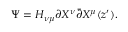Convert formula to latex. <formula><loc_0><loc_0><loc_500><loc_500>\Psi = H _ { \nu \mu } \partial X ^ { \nu } \bar { \partial } X ^ { \mu } ( z ^ { \prime } ) .</formula> 